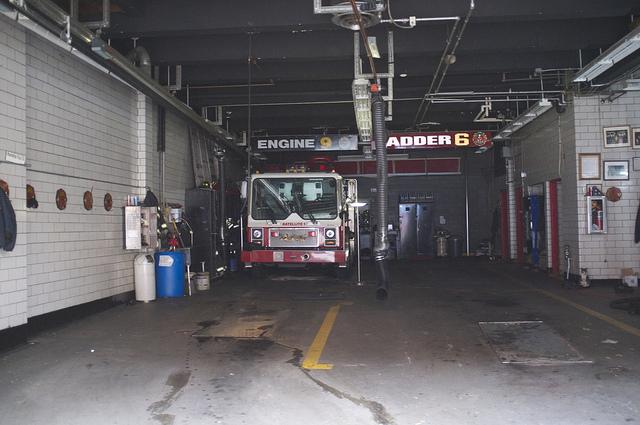Is this photo indoors or outside?
Keep it brief. Indoors. What color bricks are the walls made of?
Answer briefly. White. Where is this at?
Give a very brief answer. Fire station. What type of truck is that?
Concise answer only. Fire truck. How many trucks are in this garage?
Give a very brief answer. 1. 